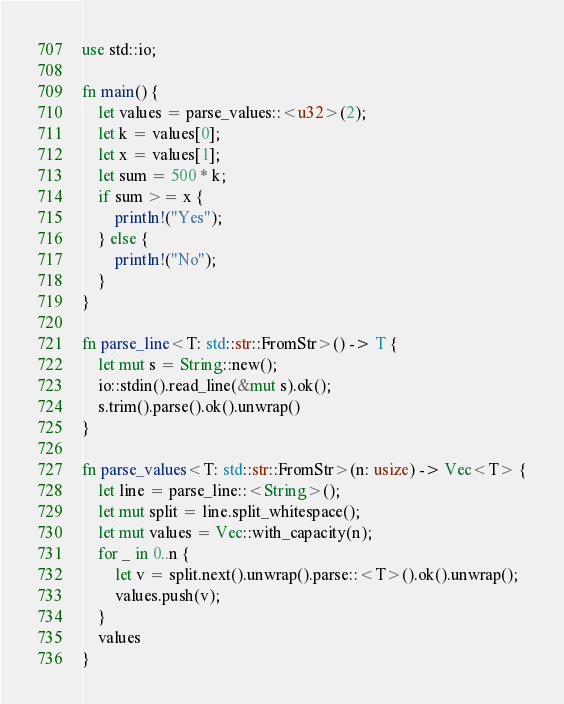Convert code to text. <code><loc_0><loc_0><loc_500><loc_500><_Rust_>use std::io;

fn main() {
    let values = parse_values::<u32>(2);
    let k = values[0];
    let x = values[1];
    let sum = 500 * k;
    if sum >= x {
        println!("Yes");
    } else {
        println!("No");
    }
}

fn parse_line<T: std::str::FromStr>() -> T {
    let mut s = String::new();
    io::stdin().read_line(&mut s).ok();
    s.trim().parse().ok().unwrap()
}

fn parse_values<T: std::str::FromStr>(n: usize) -> Vec<T> {
    let line = parse_line::<String>();
    let mut split = line.split_whitespace();
    let mut values = Vec::with_capacity(n);
    for _ in 0..n {
        let v = split.next().unwrap().parse::<T>().ok().unwrap();
        values.push(v);
    }
    values
}</code> 